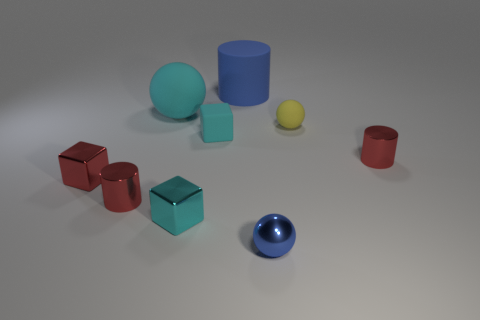Subtract all metallic blocks. How many blocks are left? 1 Add 1 small cylinders. How many objects exist? 10 Subtract all red blocks. How many blocks are left? 2 Subtract all spheres. How many objects are left? 6 Subtract 3 cylinders. How many cylinders are left? 0 Add 4 metallic cylinders. How many metallic cylinders exist? 6 Subtract 1 blue cylinders. How many objects are left? 8 Subtract all gray blocks. Subtract all green spheres. How many blocks are left? 3 Subtract all gray cubes. How many purple cylinders are left? 0 Subtract all purple metallic things. Subtract all tiny cubes. How many objects are left? 6 